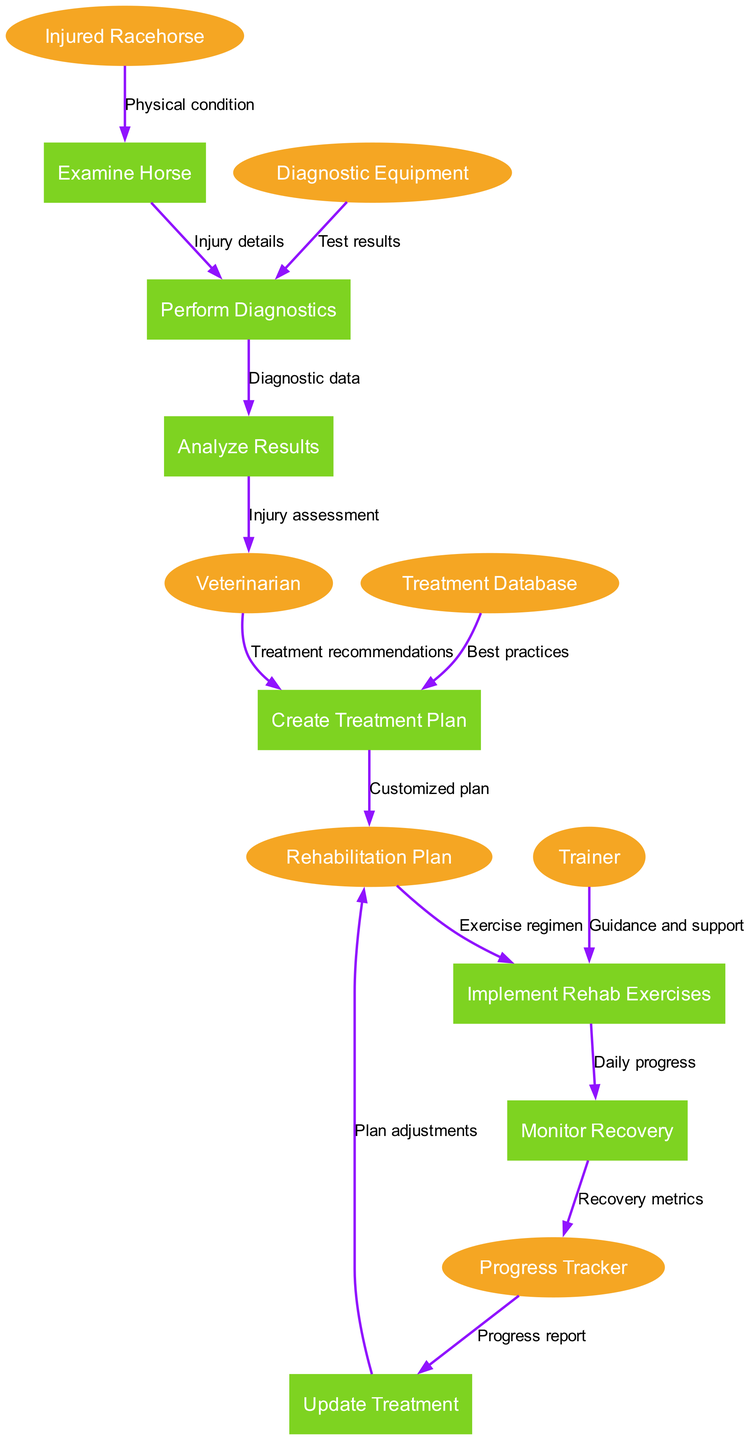What is the first process in the diagram? The first process in the diagram is "Examine Horse," as it is the initial step taken to assess the injured racehorse before any diagnostics are performed.
Answer: Examine Horse How many entities are present in the diagram? There are six entities present in the diagram, which include "Injured Racehorse," "Veterinarian," "Trainer," "Diagnostic Equipment," "Treatment Database," and "Progress Tracker."
Answer: Six What data flow leads to the "Analyze Results" process? The data flow that leads to the "Analyze Results" process comes from "Perform Diagnostics," carrying "Diagnostic data," which is essential for analyzing the results of the diagnostics performed on the horse.
Answer: Diagnostic data Which process is responsible for creating a customized plan? The process responsible for creating a customized plan is "Create Treatment Plan," where treatment recommendations from the veterinarian and best practices from the treatment database are utilized to tailor the plan for the injured racehorse.
Answer: Create Treatment Plan What metric is monitored in the "Monitor Recovery" process? In the "Monitor Recovery" process, the metric being monitored is "Daily progress," which tracks the ongoing recovery status of the horse after rehabilitation exercises have been implemented.
Answer: Daily progress Which entity provides guidance and support during the rehabilitation exercises? The entity that provides guidance and support during the rehabilitation exercises is the "Trainer," who assists the injured racehorse in performing the recommended rehab exercises according to the planned rehabilitation regimen.
Answer: Trainer What triggers the "Update Treatment" process? The "Update Treatment" process is triggered by the "Progress report," which is derived from the recovery metrics collected in the "Monitor Recovery" process, allowing for adjustments to the rehabilitation plan based on the horse's recovery status.
Answer: Progress report How many processes are connected to the "Rehabilitation Plan"? There are three processes connected to the "Rehabilitation Plan": "Create Treatment Plan," "Implement Rehab Exercises," and "Update Treatment," indicating that it plays a central role in the treatment and recovery workflow for the horse.
Answer: Three 